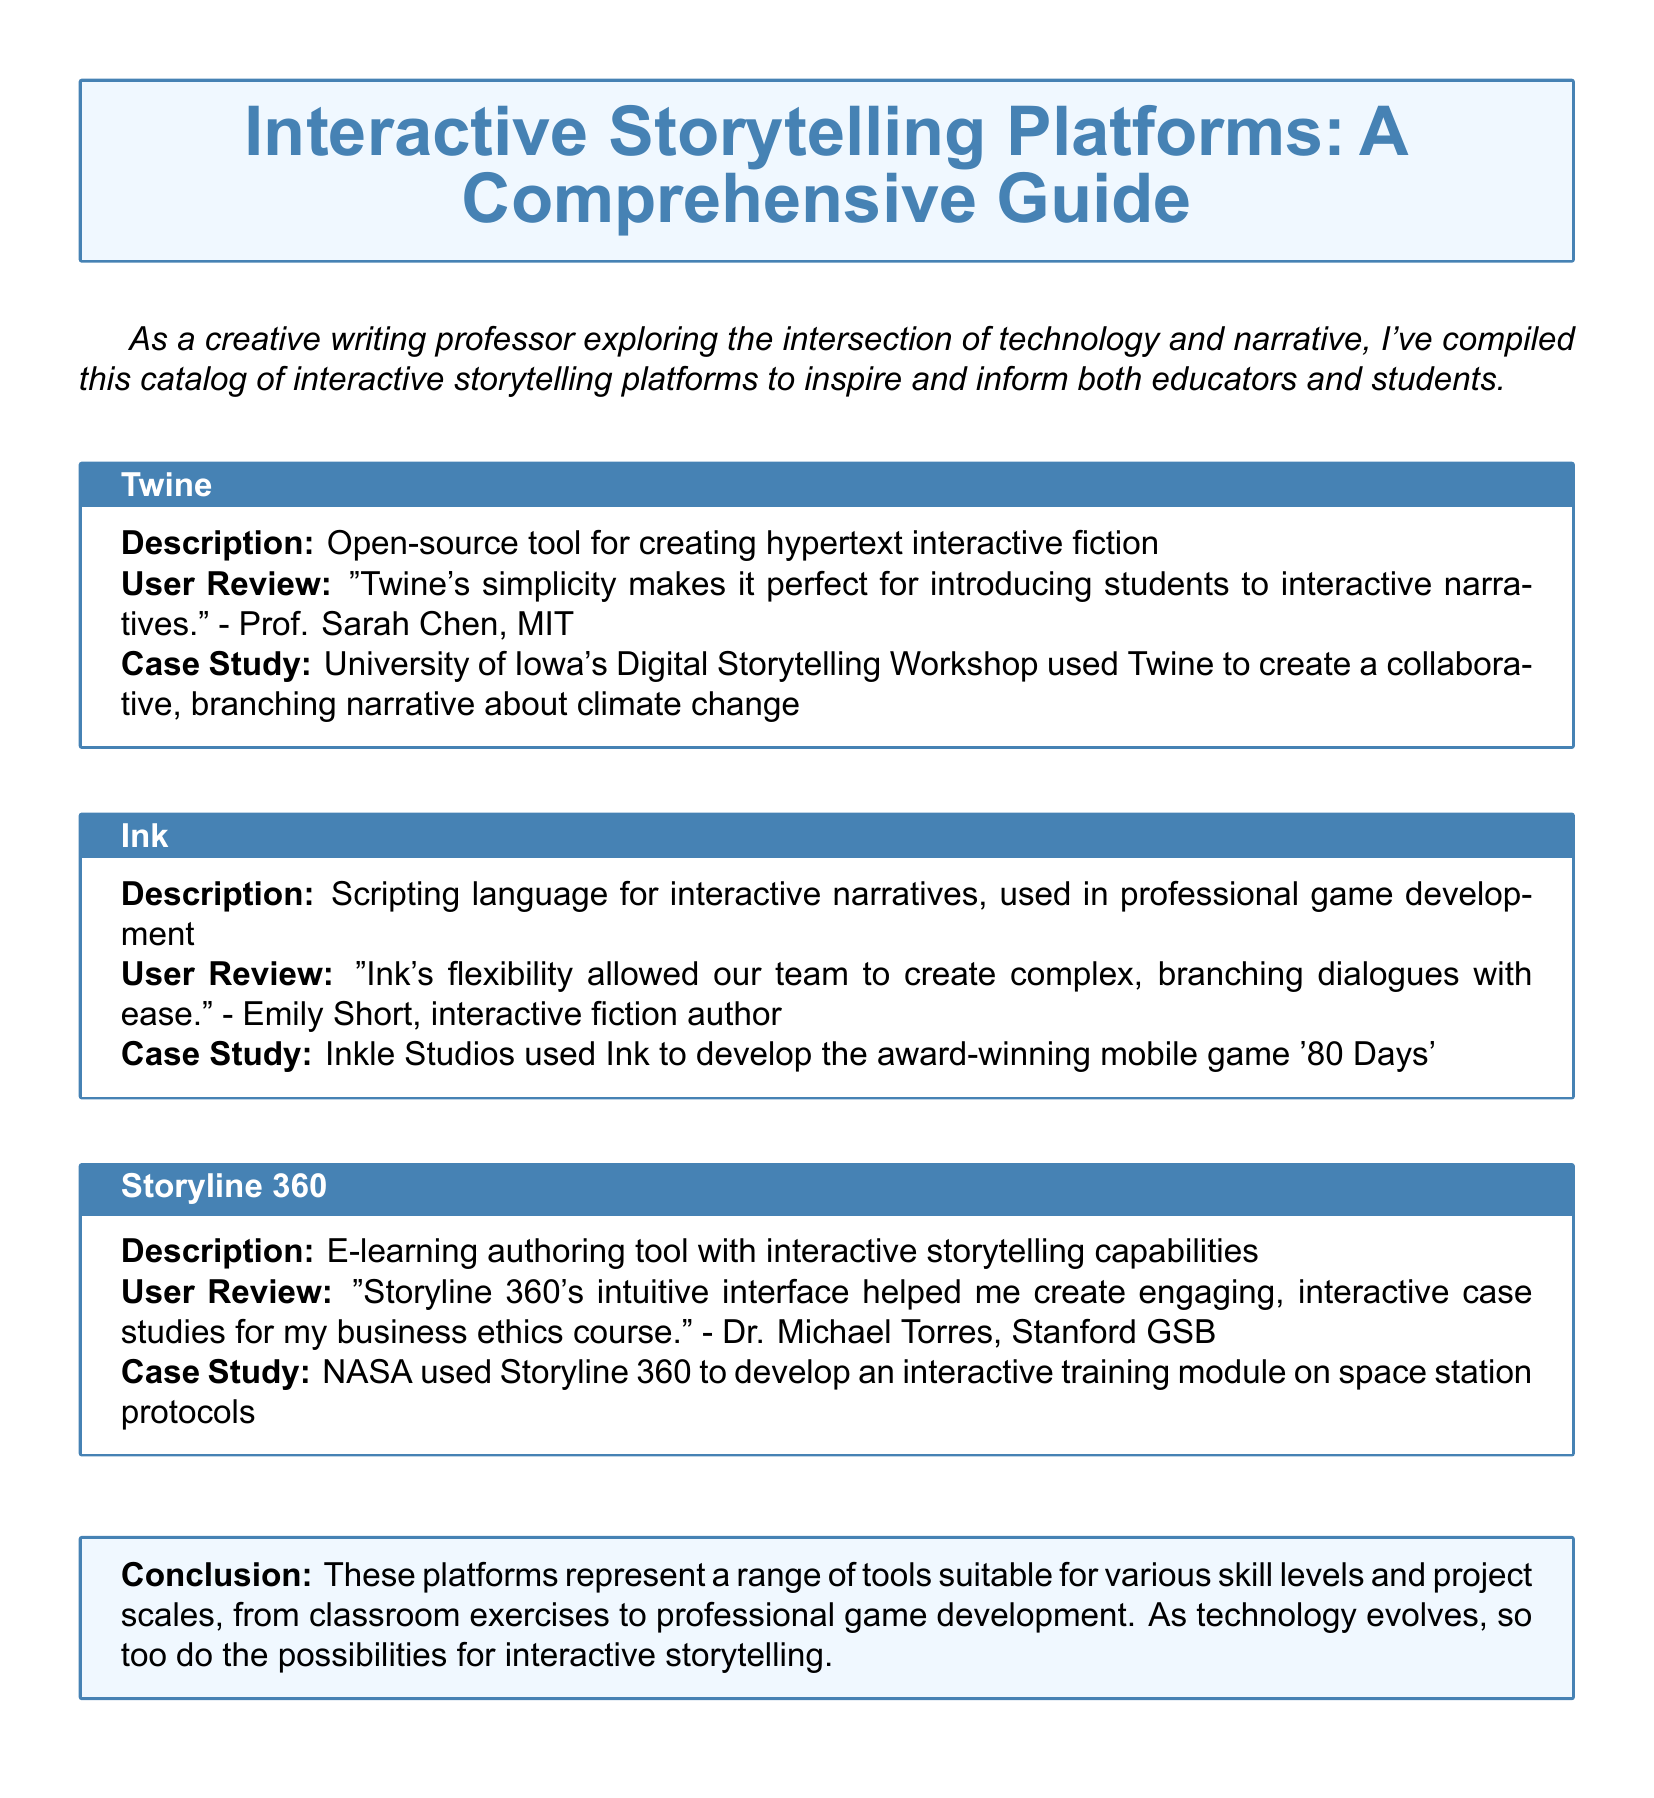What is the title of the catalog? The title of the catalog is mentioned prominently in the document as "A Comprehensive Guide."
Answer: A Comprehensive Guide Who reviewed Twine? The document states that Prof. Sarah Chen from MIT provided a review of Twine.
Answer: Prof. Sarah Chen What is the focus of the case study involving Twine? The case study involving Twine focused on creating a collaborative, branching narrative about climate change.
Answer: climate change Which platform was used to develop '80 Days'? Inkle Studios used Ink to develop the award-winning mobile game '80 Days.'
Answer: Ink Who used Storyline 360 according to the document? The document mentions that NASA used Storyline 360 to develop an interactive training module.
Answer: NASA What is the primary use of Ink as described in the catalog? Ink is described as a scripting language for interactive narratives in professional game development.
Answer: interactive narratives How does Dr. Michael Torres describe the interface of Storyline 360? Dr. Michael Torres describes the interface of Storyline 360 as intuitive.
Answer: intuitive What platforms are mentioned in the catalog? The platforms mentioned in the catalog are Twine, Ink, and Storyline 360.
Answer: Twine, Ink, and Storyline 360 